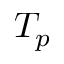<formula> <loc_0><loc_0><loc_500><loc_500>T _ { p }</formula> 